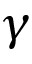<formula> <loc_0><loc_0><loc_500><loc_500>\gamma</formula> 